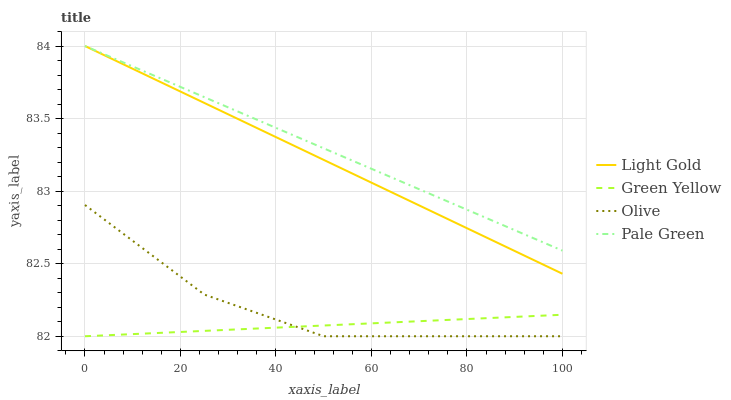Does Green Yellow have the minimum area under the curve?
Answer yes or no. Yes. Does Pale Green have the maximum area under the curve?
Answer yes or no. Yes. Does Pale Green have the minimum area under the curve?
Answer yes or no. No. Does Green Yellow have the maximum area under the curve?
Answer yes or no. No. Is Light Gold the smoothest?
Answer yes or no. Yes. Is Olive the roughest?
Answer yes or no. Yes. Is Pale Green the smoothest?
Answer yes or no. No. Is Pale Green the roughest?
Answer yes or no. No. Does Olive have the lowest value?
Answer yes or no. Yes. Does Pale Green have the lowest value?
Answer yes or no. No. Does Light Gold have the highest value?
Answer yes or no. Yes. Does Green Yellow have the highest value?
Answer yes or no. No. Is Olive less than Light Gold?
Answer yes or no. Yes. Is Light Gold greater than Green Yellow?
Answer yes or no. Yes. Does Light Gold intersect Pale Green?
Answer yes or no. Yes. Is Light Gold less than Pale Green?
Answer yes or no. No. Is Light Gold greater than Pale Green?
Answer yes or no. No. Does Olive intersect Light Gold?
Answer yes or no. No. 